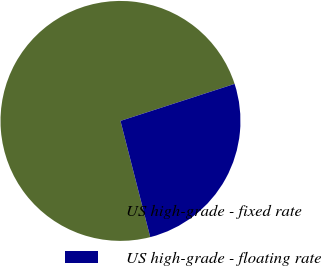Convert chart to OTSL. <chart><loc_0><loc_0><loc_500><loc_500><pie_chart><fcel>US high-grade - fixed rate<fcel>US high-grade - floating rate<nl><fcel>74.0%<fcel>26.0%<nl></chart> 